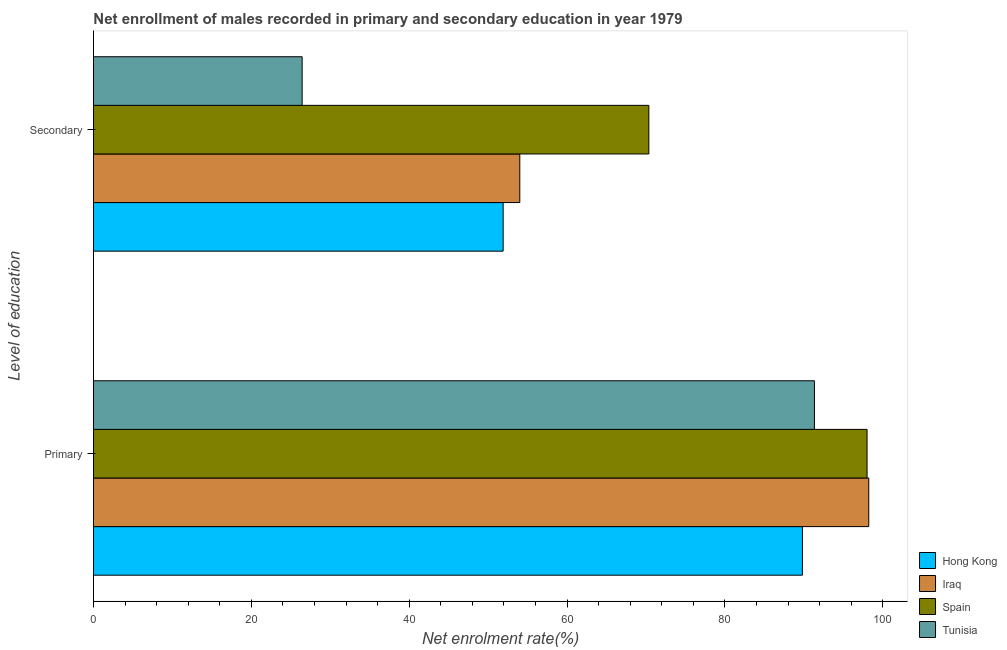How many different coloured bars are there?
Offer a terse response. 4. Are the number of bars per tick equal to the number of legend labels?
Your answer should be very brief. Yes. How many bars are there on the 2nd tick from the top?
Keep it short and to the point. 4. How many bars are there on the 1st tick from the bottom?
Your response must be concise. 4. What is the label of the 2nd group of bars from the top?
Provide a succinct answer. Primary. What is the enrollment rate in secondary education in Iraq?
Offer a very short reply. 54.02. Across all countries, what is the maximum enrollment rate in secondary education?
Make the answer very short. 70.37. Across all countries, what is the minimum enrollment rate in primary education?
Give a very brief answer. 89.82. In which country was the enrollment rate in primary education maximum?
Provide a succinct answer. Iraq. In which country was the enrollment rate in primary education minimum?
Offer a very short reply. Hong Kong. What is the total enrollment rate in primary education in the graph?
Your answer should be compact. 377.42. What is the difference between the enrollment rate in primary education in Tunisia and that in Iraq?
Keep it short and to the point. -6.88. What is the difference between the enrollment rate in secondary education in Spain and the enrollment rate in primary education in Tunisia?
Keep it short and to the point. -20.98. What is the average enrollment rate in primary education per country?
Offer a terse response. 94.36. What is the difference between the enrollment rate in primary education and enrollment rate in secondary education in Spain?
Your answer should be very brief. 27.65. What is the ratio of the enrollment rate in secondary education in Iraq to that in Spain?
Offer a terse response. 0.77. Is the enrollment rate in primary education in Tunisia less than that in Spain?
Offer a very short reply. Yes. What does the 1st bar from the top in Secondary represents?
Keep it short and to the point. Tunisia. Are all the bars in the graph horizontal?
Provide a succinct answer. Yes. What is the difference between two consecutive major ticks on the X-axis?
Your response must be concise. 20. Does the graph contain any zero values?
Provide a short and direct response. No. Does the graph contain grids?
Ensure brevity in your answer.  No. What is the title of the graph?
Your answer should be very brief. Net enrollment of males recorded in primary and secondary education in year 1979. What is the label or title of the X-axis?
Provide a short and direct response. Net enrolment rate(%). What is the label or title of the Y-axis?
Ensure brevity in your answer.  Level of education. What is the Net enrolment rate(%) in Hong Kong in Primary?
Your response must be concise. 89.82. What is the Net enrolment rate(%) in Iraq in Primary?
Your answer should be compact. 98.23. What is the Net enrolment rate(%) in Spain in Primary?
Your answer should be very brief. 98.02. What is the Net enrolment rate(%) in Tunisia in Primary?
Provide a succinct answer. 91.35. What is the Net enrolment rate(%) in Hong Kong in Secondary?
Give a very brief answer. 51.91. What is the Net enrolment rate(%) of Iraq in Secondary?
Ensure brevity in your answer.  54.02. What is the Net enrolment rate(%) in Spain in Secondary?
Your answer should be very brief. 70.37. What is the Net enrolment rate(%) of Tunisia in Secondary?
Your answer should be compact. 26.44. Across all Level of education, what is the maximum Net enrolment rate(%) in Hong Kong?
Your answer should be compact. 89.82. Across all Level of education, what is the maximum Net enrolment rate(%) of Iraq?
Provide a succinct answer. 98.23. Across all Level of education, what is the maximum Net enrolment rate(%) of Spain?
Your answer should be very brief. 98.02. Across all Level of education, what is the maximum Net enrolment rate(%) in Tunisia?
Give a very brief answer. 91.35. Across all Level of education, what is the minimum Net enrolment rate(%) of Hong Kong?
Your response must be concise. 51.91. Across all Level of education, what is the minimum Net enrolment rate(%) in Iraq?
Provide a short and direct response. 54.02. Across all Level of education, what is the minimum Net enrolment rate(%) of Spain?
Provide a succinct answer. 70.37. Across all Level of education, what is the minimum Net enrolment rate(%) in Tunisia?
Keep it short and to the point. 26.44. What is the total Net enrolment rate(%) in Hong Kong in the graph?
Give a very brief answer. 141.73. What is the total Net enrolment rate(%) of Iraq in the graph?
Your answer should be compact. 152.25. What is the total Net enrolment rate(%) of Spain in the graph?
Your answer should be very brief. 168.39. What is the total Net enrolment rate(%) of Tunisia in the graph?
Provide a short and direct response. 117.79. What is the difference between the Net enrolment rate(%) of Hong Kong in Primary and that in Secondary?
Your response must be concise. 37.92. What is the difference between the Net enrolment rate(%) in Iraq in Primary and that in Secondary?
Your answer should be very brief. 44.21. What is the difference between the Net enrolment rate(%) in Spain in Primary and that in Secondary?
Keep it short and to the point. 27.65. What is the difference between the Net enrolment rate(%) in Tunisia in Primary and that in Secondary?
Offer a terse response. 64.91. What is the difference between the Net enrolment rate(%) in Hong Kong in Primary and the Net enrolment rate(%) in Iraq in Secondary?
Make the answer very short. 35.81. What is the difference between the Net enrolment rate(%) in Hong Kong in Primary and the Net enrolment rate(%) in Spain in Secondary?
Keep it short and to the point. 19.46. What is the difference between the Net enrolment rate(%) of Hong Kong in Primary and the Net enrolment rate(%) of Tunisia in Secondary?
Your response must be concise. 63.38. What is the difference between the Net enrolment rate(%) in Iraq in Primary and the Net enrolment rate(%) in Spain in Secondary?
Give a very brief answer. 27.86. What is the difference between the Net enrolment rate(%) of Iraq in Primary and the Net enrolment rate(%) of Tunisia in Secondary?
Your response must be concise. 71.79. What is the difference between the Net enrolment rate(%) of Spain in Primary and the Net enrolment rate(%) of Tunisia in Secondary?
Ensure brevity in your answer.  71.58. What is the average Net enrolment rate(%) of Hong Kong per Level of education?
Provide a succinct answer. 70.87. What is the average Net enrolment rate(%) in Iraq per Level of education?
Your answer should be very brief. 76.13. What is the average Net enrolment rate(%) of Spain per Level of education?
Ensure brevity in your answer.  84.19. What is the average Net enrolment rate(%) in Tunisia per Level of education?
Keep it short and to the point. 58.89. What is the difference between the Net enrolment rate(%) in Hong Kong and Net enrolment rate(%) in Iraq in Primary?
Your response must be concise. -8.41. What is the difference between the Net enrolment rate(%) of Hong Kong and Net enrolment rate(%) of Spain in Primary?
Keep it short and to the point. -8.19. What is the difference between the Net enrolment rate(%) in Hong Kong and Net enrolment rate(%) in Tunisia in Primary?
Your response must be concise. -1.52. What is the difference between the Net enrolment rate(%) of Iraq and Net enrolment rate(%) of Spain in Primary?
Keep it short and to the point. 0.21. What is the difference between the Net enrolment rate(%) of Iraq and Net enrolment rate(%) of Tunisia in Primary?
Keep it short and to the point. 6.88. What is the difference between the Net enrolment rate(%) in Spain and Net enrolment rate(%) in Tunisia in Primary?
Your answer should be compact. 6.67. What is the difference between the Net enrolment rate(%) in Hong Kong and Net enrolment rate(%) in Iraq in Secondary?
Offer a very short reply. -2.11. What is the difference between the Net enrolment rate(%) in Hong Kong and Net enrolment rate(%) in Spain in Secondary?
Give a very brief answer. -18.46. What is the difference between the Net enrolment rate(%) of Hong Kong and Net enrolment rate(%) of Tunisia in Secondary?
Your answer should be compact. 25.47. What is the difference between the Net enrolment rate(%) of Iraq and Net enrolment rate(%) of Spain in Secondary?
Make the answer very short. -16.35. What is the difference between the Net enrolment rate(%) in Iraq and Net enrolment rate(%) in Tunisia in Secondary?
Your answer should be very brief. 27.58. What is the difference between the Net enrolment rate(%) of Spain and Net enrolment rate(%) of Tunisia in Secondary?
Your response must be concise. 43.93. What is the ratio of the Net enrolment rate(%) of Hong Kong in Primary to that in Secondary?
Make the answer very short. 1.73. What is the ratio of the Net enrolment rate(%) in Iraq in Primary to that in Secondary?
Give a very brief answer. 1.82. What is the ratio of the Net enrolment rate(%) of Spain in Primary to that in Secondary?
Provide a short and direct response. 1.39. What is the ratio of the Net enrolment rate(%) in Tunisia in Primary to that in Secondary?
Your response must be concise. 3.45. What is the difference between the highest and the second highest Net enrolment rate(%) in Hong Kong?
Your response must be concise. 37.92. What is the difference between the highest and the second highest Net enrolment rate(%) of Iraq?
Ensure brevity in your answer.  44.21. What is the difference between the highest and the second highest Net enrolment rate(%) of Spain?
Offer a terse response. 27.65. What is the difference between the highest and the second highest Net enrolment rate(%) in Tunisia?
Ensure brevity in your answer.  64.91. What is the difference between the highest and the lowest Net enrolment rate(%) in Hong Kong?
Your answer should be very brief. 37.92. What is the difference between the highest and the lowest Net enrolment rate(%) of Iraq?
Offer a very short reply. 44.21. What is the difference between the highest and the lowest Net enrolment rate(%) of Spain?
Offer a very short reply. 27.65. What is the difference between the highest and the lowest Net enrolment rate(%) of Tunisia?
Give a very brief answer. 64.91. 